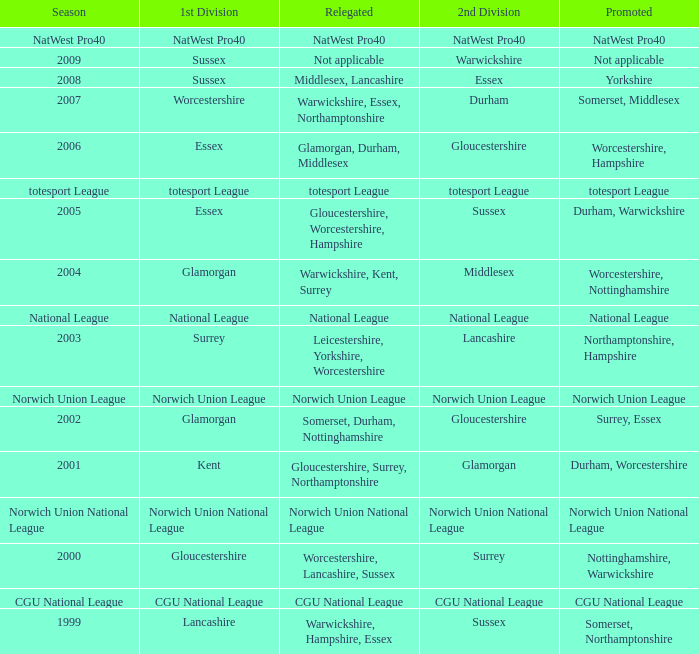What was relegated in the 2006 season? Glamorgan, Durham, Middlesex. 